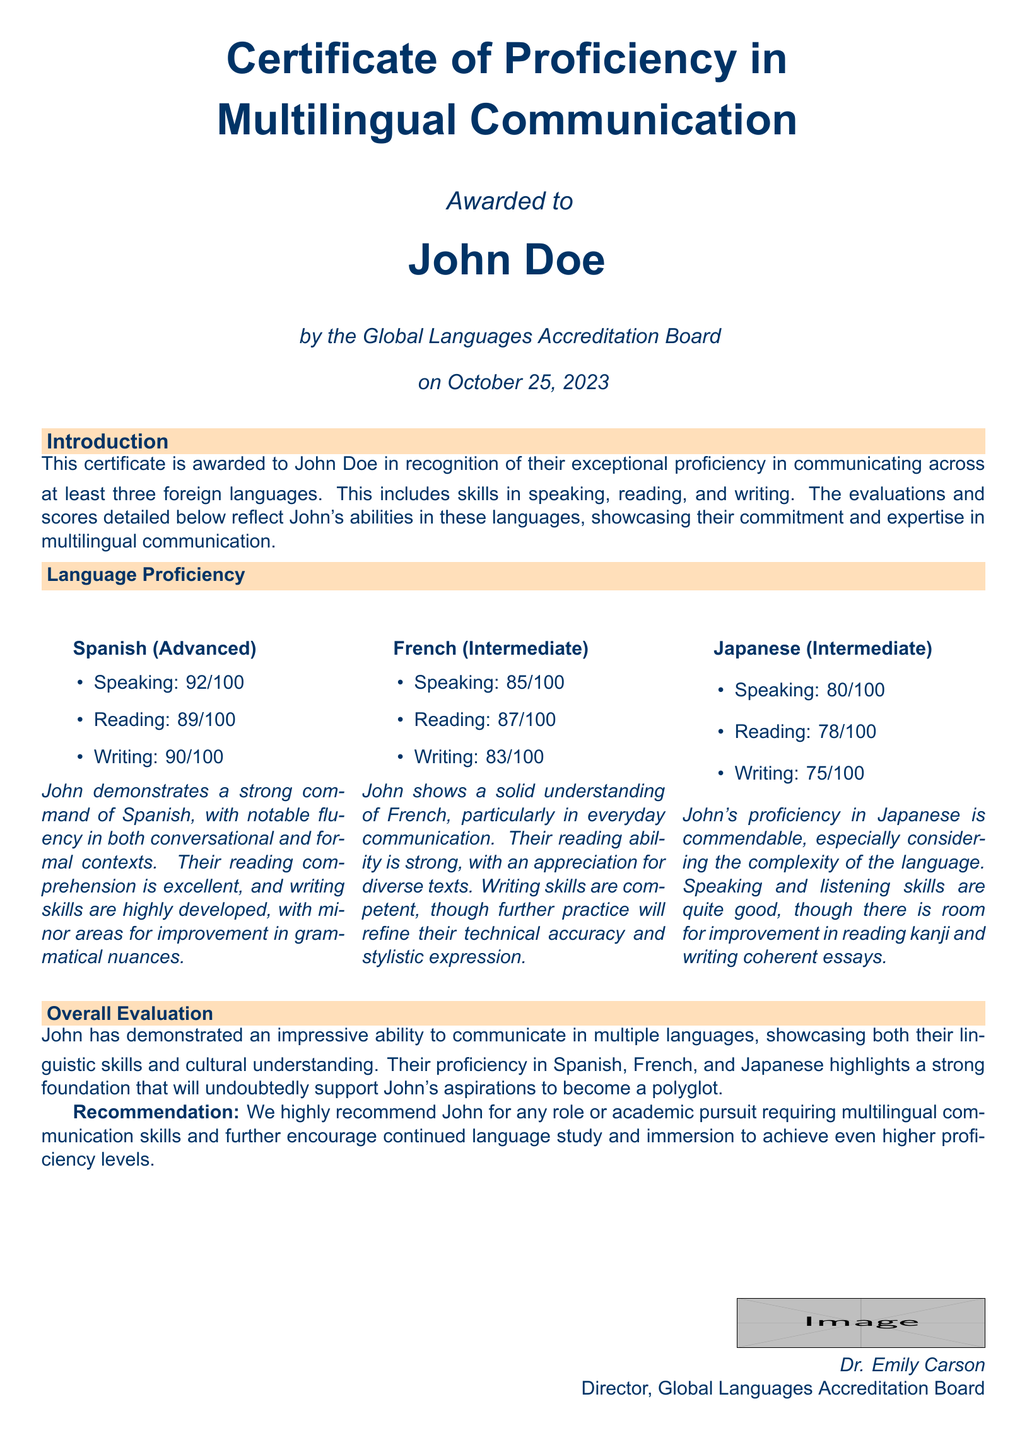What is the name of the certificate? The document is titled "Certificate of Proficiency in Multilingual Communication."
Answer: Certificate of Proficiency in Multilingual Communication Who is the certificate awarded to? The document specifies the name of the individual receiving the certificate.
Answer: John Doe When was the certificate awarded? The date mentioned in the document indicates when the certificate was issued.
Answer: October 25, 2023 What is John Doe’s speaking score in Spanish? The evaluation section lists the speaking score specifically for Spanish.
Answer: 92/100 Which language has the highest average score? The average scores of all three languages are compared to determine which is highest.
Answer: Spanish What is the level of proficiency in French? The document clearly states the level of proficiency in each language.
Answer: Intermediate What is the writing score for Japanese? The document lists the score specifically for writing in Japanese.
Answer: 75/100 What is the recommendation for John Doe? The document provides a recommendation pertaining to roles or academic pursuits requiring multilingual skills.
Answer: We highly recommend John for any role or academic pursuit requiring multilingual communication skills How many languages does John demonstrate proficiency in? The introduction specifies the number of foreign languages included in the proficiency evaluation.
Answer: At least three 